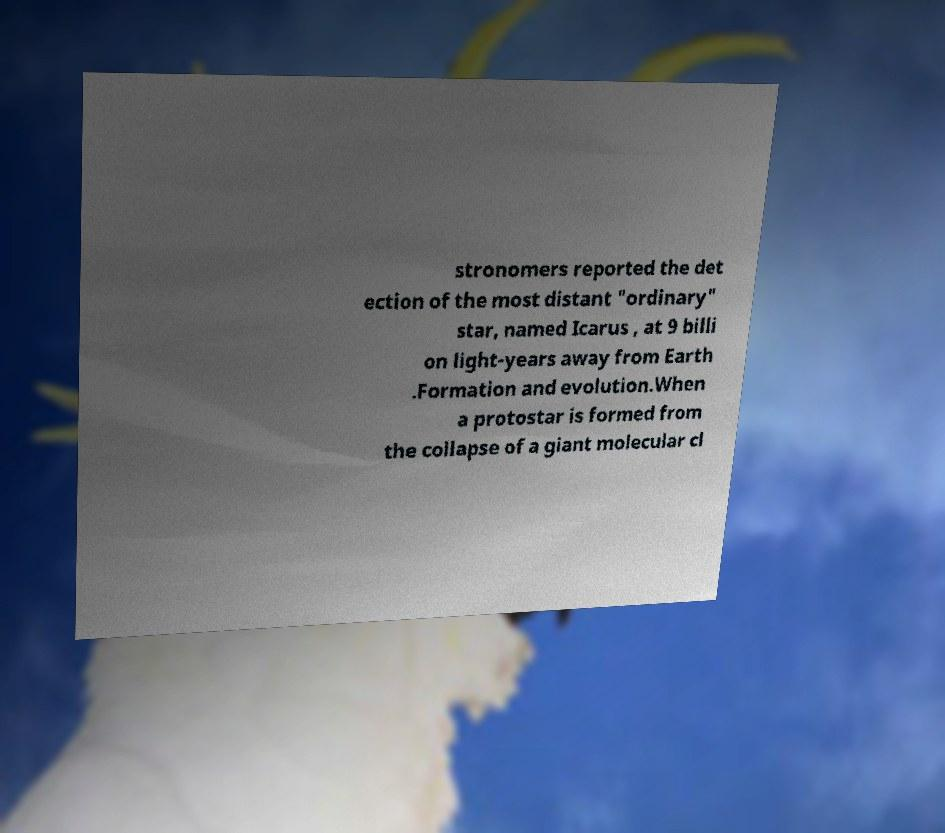There's text embedded in this image that I need extracted. Can you transcribe it verbatim? stronomers reported the det ection of the most distant "ordinary" star, named Icarus , at 9 billi on light-years away from Earth .Formation and evolution.When a protostar is formed from the collapse of a giant molecular cl 